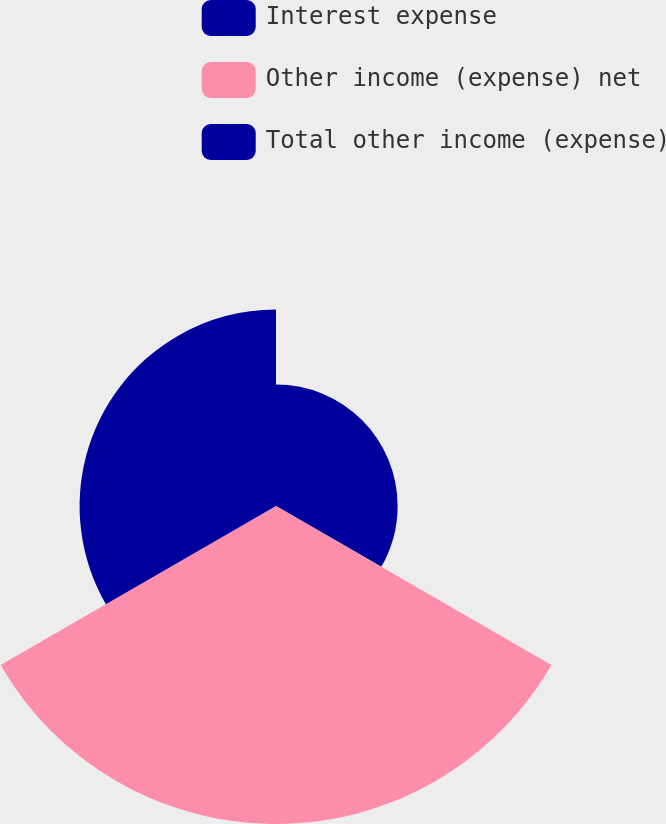Convert chart to OTSL. <chart><loc_0><loc_0><loc_500><loc_500><pie_chart><fcel>Interest expense<fcel>Other income (expense) net<fcel>Total other income (expense)<nl><fcel>19.12%<fcel>50.0%<fcel>30.88%<nl></chart> 